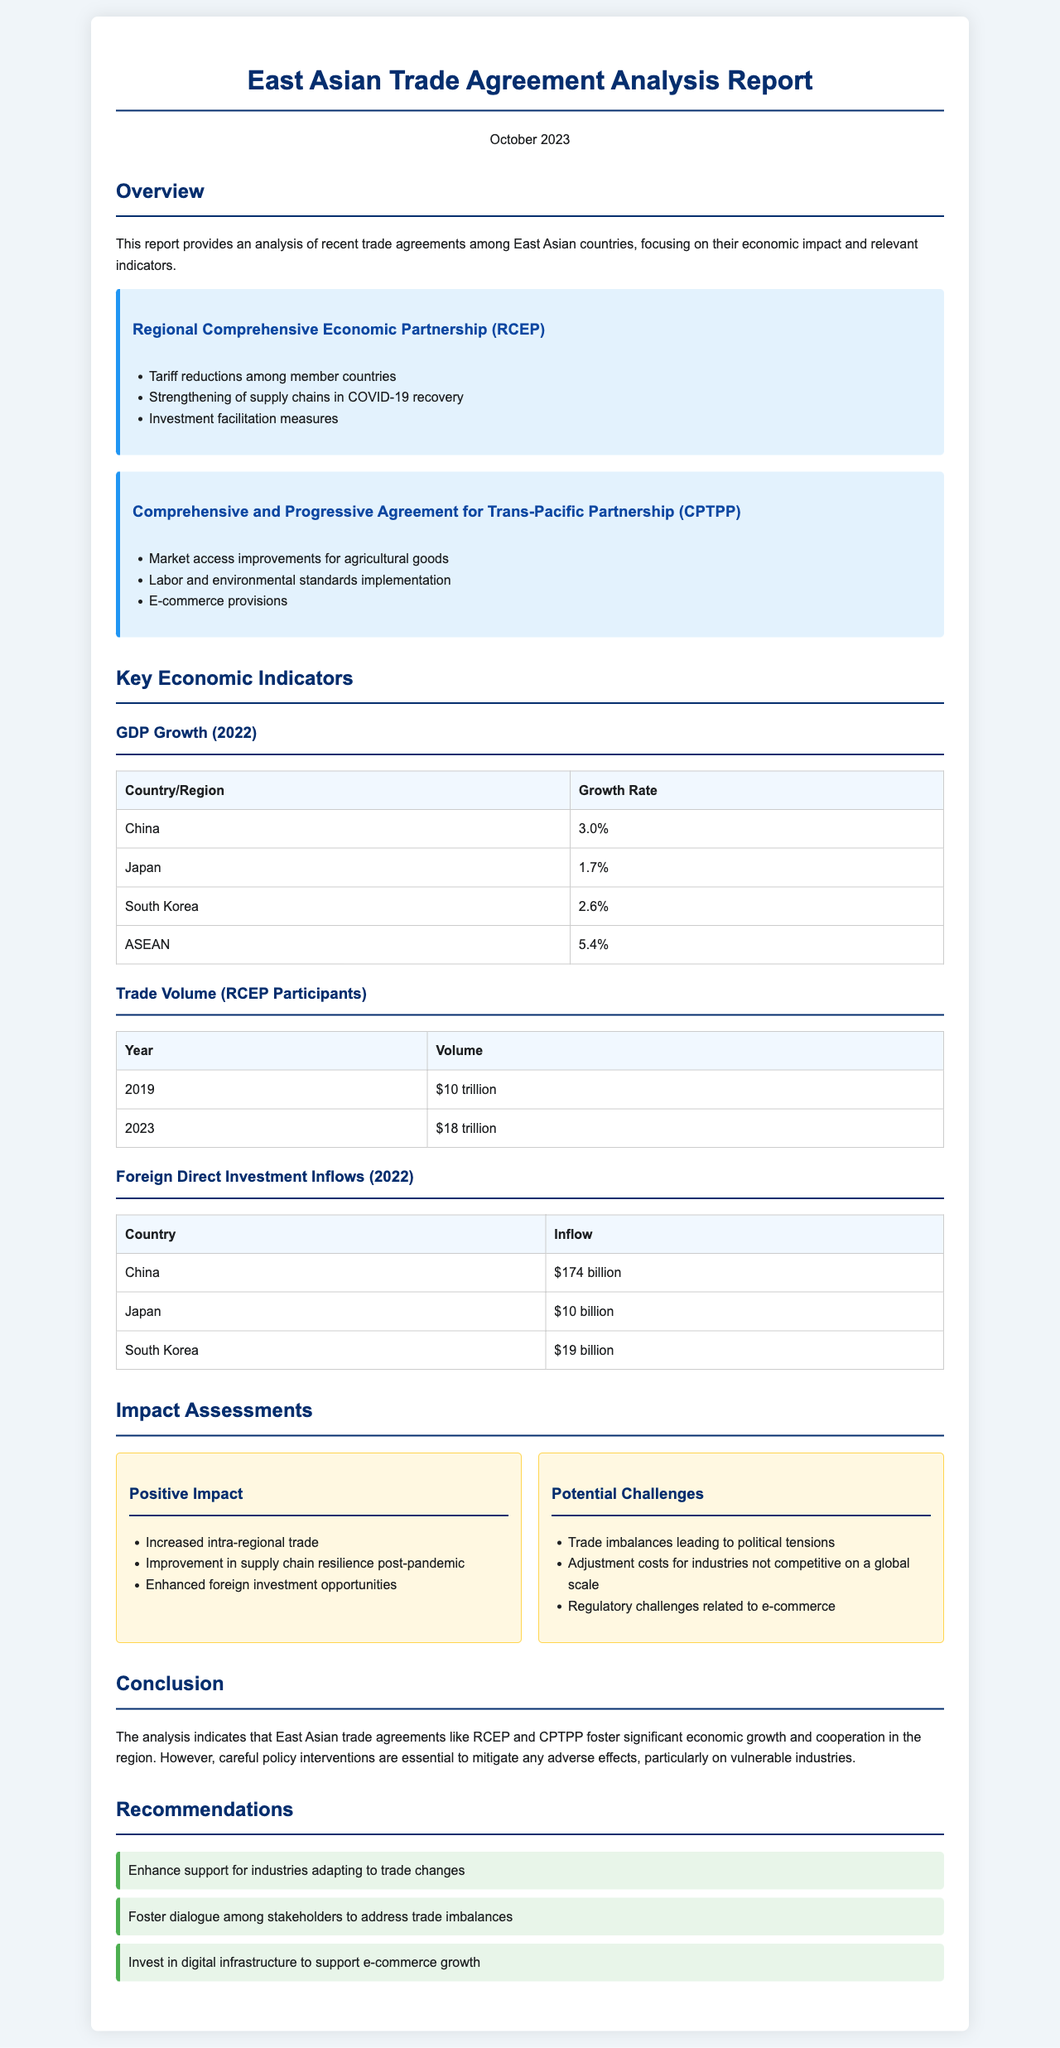What is the main focus of the report? The report provides an analysis of recent trade agreements among East Asian countries, focusing on their economic impact and relevant indicators.
Answer: Economic impact and relevant indicators What is the GDP growth rate for Japan in 2022? The GDP growth rate for Japan is specifically mentioned in the Key Economic Indicators section.
Answer: 1.7% What trade agreement is associated with tariff reductions among member countries? The document lists this trade agreement in the Overview section, emphasizing its features.
Answer: Regional Comprehensive Economic Partnership (RCEP) What was the trade volume among RCEP participants in 2023? The document provides specific trade volume figures for 2019 and 2023 in a table.
Answer: $18 trillion What positive impact is associated with East Asian trade agreements? The document lists specific positive impacts in the Impact Assessments section.
Answer: Increased intra-regional trade Which country received the highest foreign direct investment inflow in 2022? The document outlines foreign direct investment inflows by country, allowing for a clear comparison.
Answer: China What is one of the recommendations given in the report? The report presents a list of recommendations in the Recommendations section for mitigating adverse effects.
Answer: Enhance support for industries adapting to trade changes What percentage of GDP growth did ASEAN achieve in 2022? The GDP growth data for different regions includes specific figures for ASEAN.
Answer: 5.4% What are the potential challenges mentioned regarding East Asian trade agreements? The document provides a list of potential challenges in the Impact Assessments section.
Answer: Trade imbalances leading to political tensions 